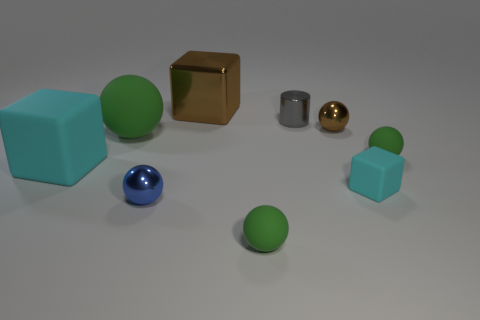What number of things are either tiny cubes in front of the large brown cube or green objects that are in front of the big rubber block?
Keep it short and to the point. 2. Do the tiny gray cylinder and the cyan cube to the right of the small gray object have the same material?
Your response must be concise. No. How many other objects are the same shape as the tiny blue thing?
Offer a terse response. 4. There is a tiny object that is left of the green thing in front of the tiny green matte thing that is behind the small cyan rubber cube; what is it made of?
Your response must be concise. Metal. Are there an equal number of brown metallic cubes that are behind the small cyan rubber object and big brown objects?
Ensure brevity in your answer.  Yes. Does the small green sphere on the left side of the tiny brown metal object have the same material as the tiny gray cylinder to the left of the small cube?
Make the answer very short. No. Is the shape of the brown shiny thing that is behind the gray metal thing the same as the cyan rubber object that is on the left side of the tiny cyan object?
Your answer should be very brief. Yes. Are there fewer tiny shiny objects that are behind the blue thing than rubber things?
Your answer should be very brief. Yes. How many tiny things are the same color as the cylinder?
Give a very brief answer. 0. What is the size of the cyan rubber cube that is left of the brown cube?
Give a very brief answer. Large. 